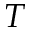Convert formula to latex. <formula><loc_0><loc_0><loc_500><loc_500>T</formula> 